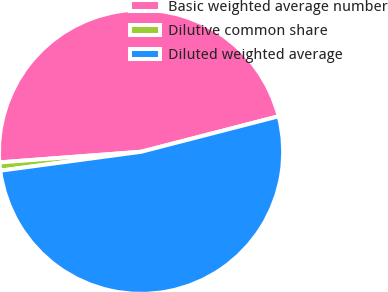Convert chart. <chart><loc_0><loc_0><loc_500><loc_500><pie_chart><fcel>Basic weighted average number<fcel>Dilutive common share<fcel>Diluted weighted average<nl><fcel>47.18%<fcel>0.93%<fcel>51.9%<nl></chart> 